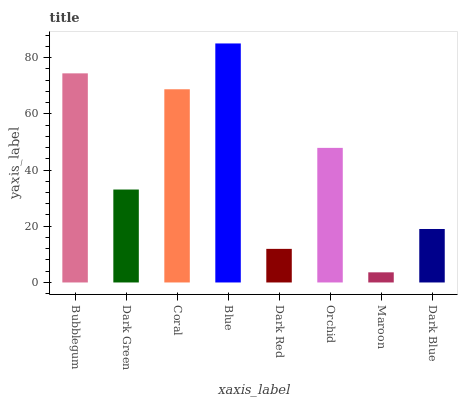Is Maroon the minimum?
Answer yes or no. Yes. Is Blue the maximum?
Answer yes or no. Yes. Is Dark Green the minimum?
Answer yes or no. No. Is Dark Green the maximum?
Answer yes or no. No. Is Bubblegum greater than Dark Green?
Answer yes or no. Yes. Is Dark Green less than Bubblegum?
Answer yes or no. Yes. Is Dark Green greater than Bubblegum?
Answer yes or no. No. Is Bubblegum less than Dark Green?
Answer yes or no. No. Is Orchid the high median?
Answer yes or no. Yes. Is Dark Green the low median?
Answer yes or no. Yes. Is Dark Blue the high median?
Answer yes or no. No. Is Bubblegum the low median?
Answer yes or no. No. 